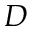<formula> <loc_0><loc_0><loc_500><loc_500>D</formula> 